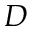<formula> <loc_0><loc_0><loc_500><loc_500>D</formula> 